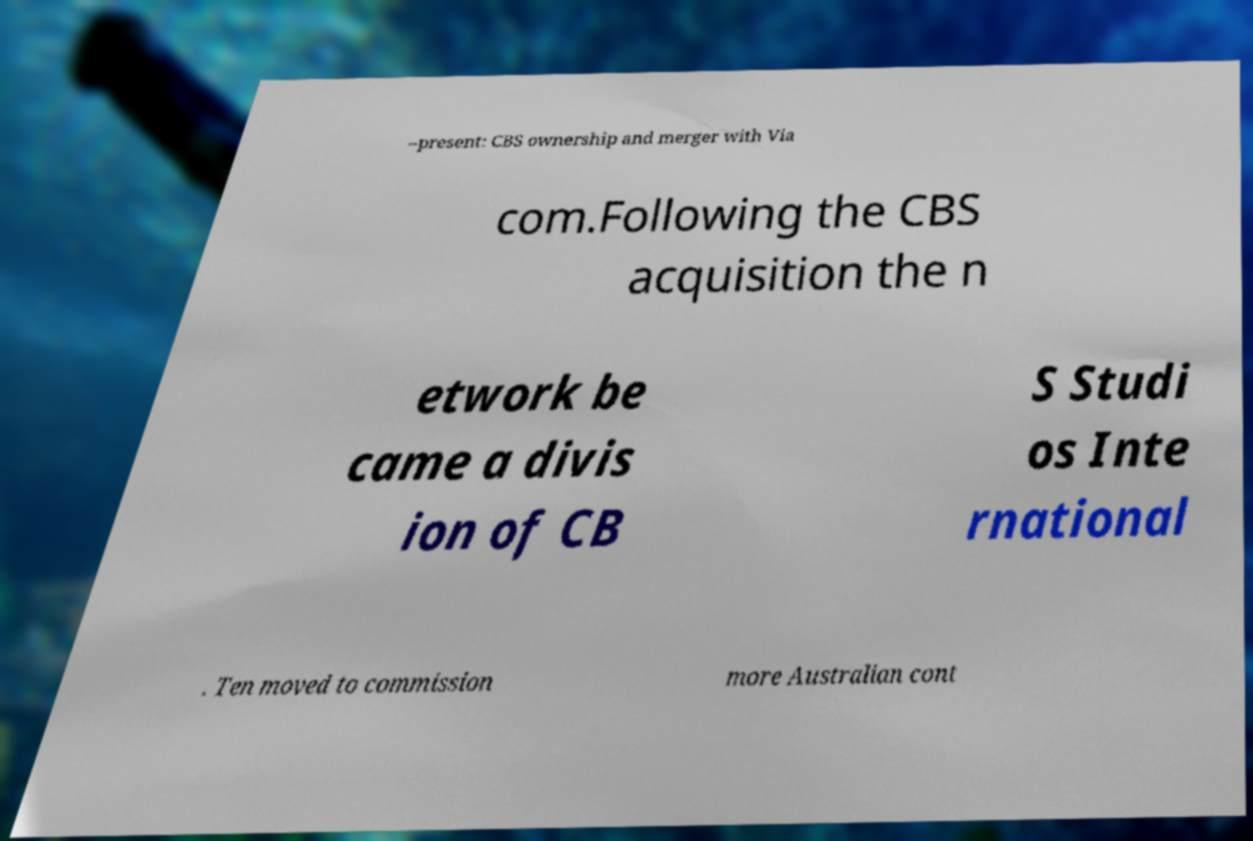Could you assist in decoding the text presented in this image and type it out clearly? –present: CBS ownership and merger with Via com.Following the CBS acquisition the n etwork be came a divis ion of CB S Studi os Inte rnational . Ten moved to commission more Australian cont 